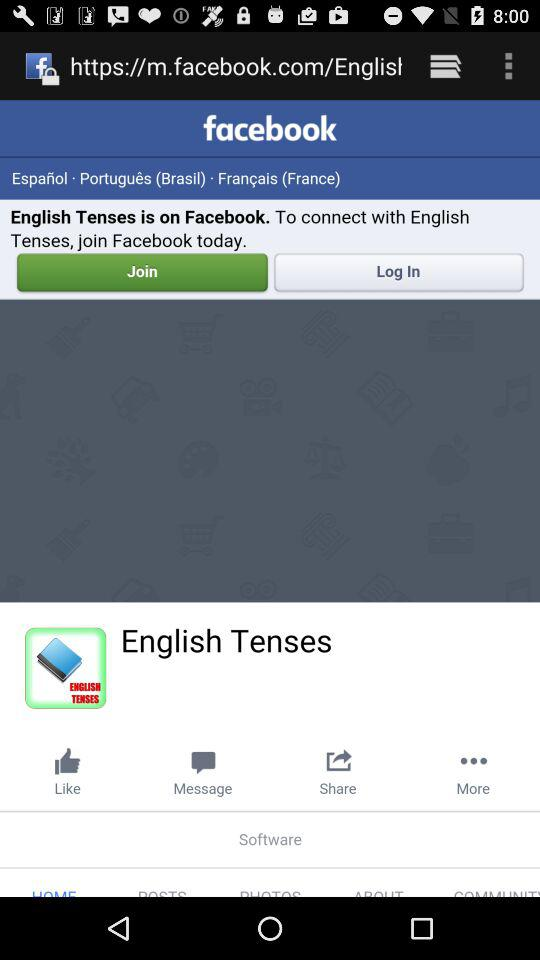Who is on "Facebook"? The one who is on "Facebook" is "English Tenses". 